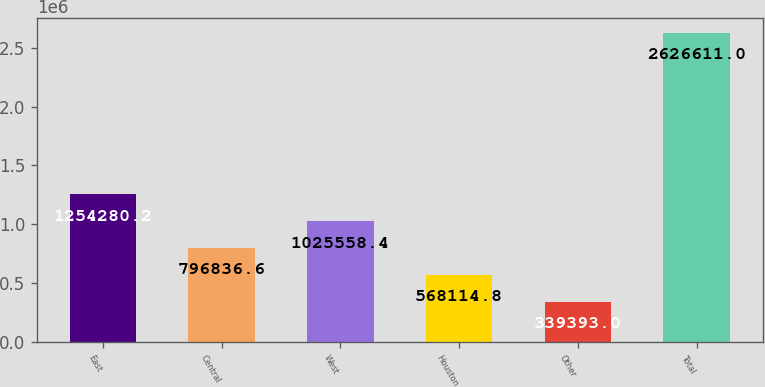Convert chart. <chart><loc_0><loc_0><loc_500><loc_500><bar_chart><fcel>East<fcel>Central<fcel>West<fcel>Houston<fcel>Other<fcel>Total<nl><fcel>1.25428e+06<fcel>796837<fcel>1.02556e+06<fcel>568115<fcel>339393<fcel>2.62661e+06<nl></chart> 